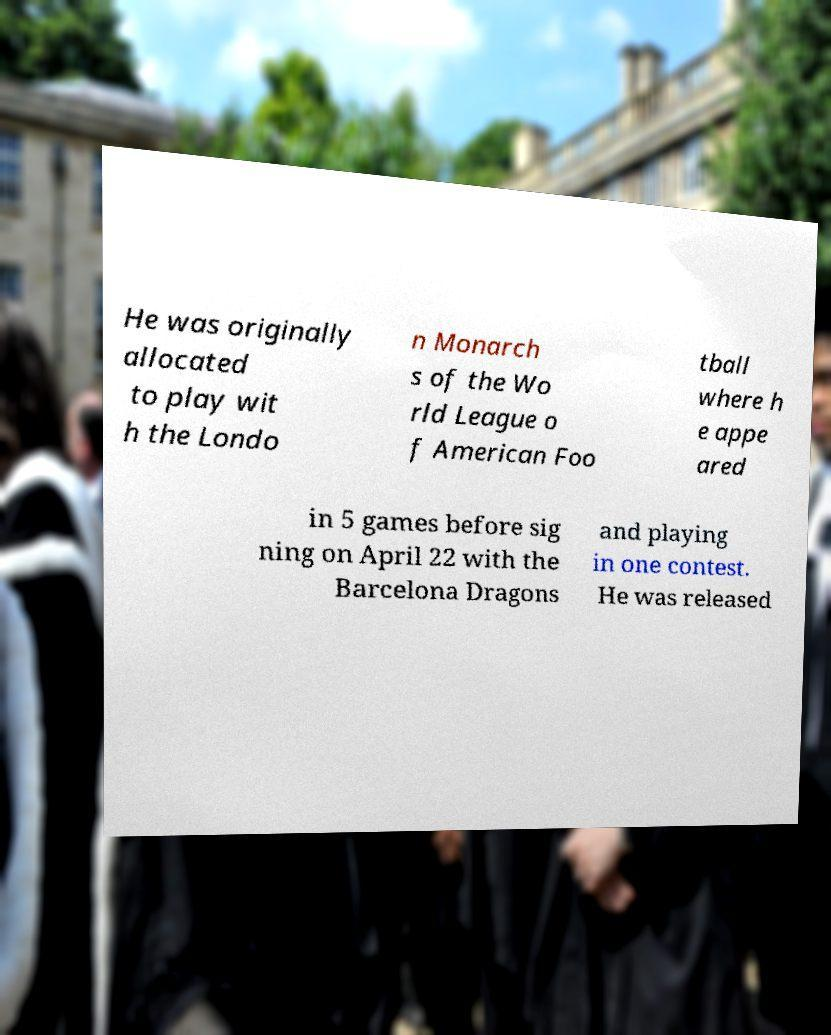Can you read and provide the text displayed in the image?This photo seems to have some interesting text. Can you extract and type it out for me? He was originally allocated to play wit h the Londo n Monarch s of the Wo rld League o f American Foo tball where h e appe ared in 5 games before sig ning on April 22 with the Barcelona Dragons and playing in one contest. He was released 